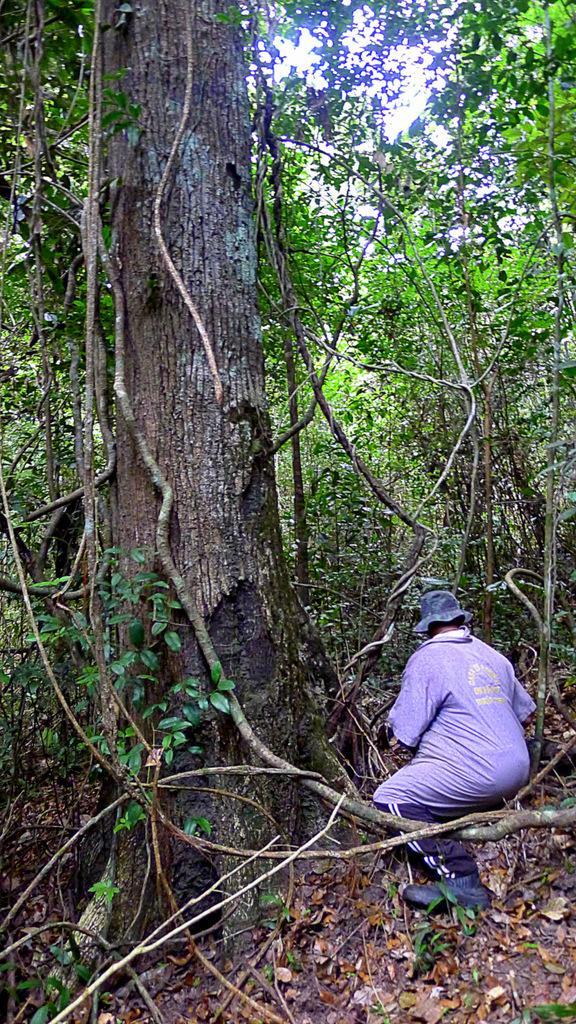Please provide a concise description of this image. This image consists of a man sitting on a stem. At the bottom, there are dried leaves on the ground. It looks like, it is clicked in a forest. In the background, there are many trees. 